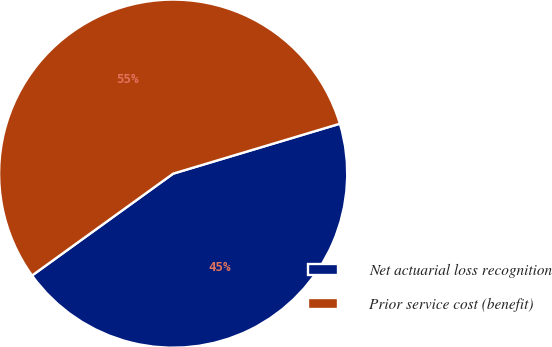<chart> <loc_0><loc_0><loc_500><loc_500><pie_chart><fcel>Net actuarial loss recognition<fcel>Prior service cost (benefit)<nl><fcel>44.68%<fcel>55.32%<nl></chart> 